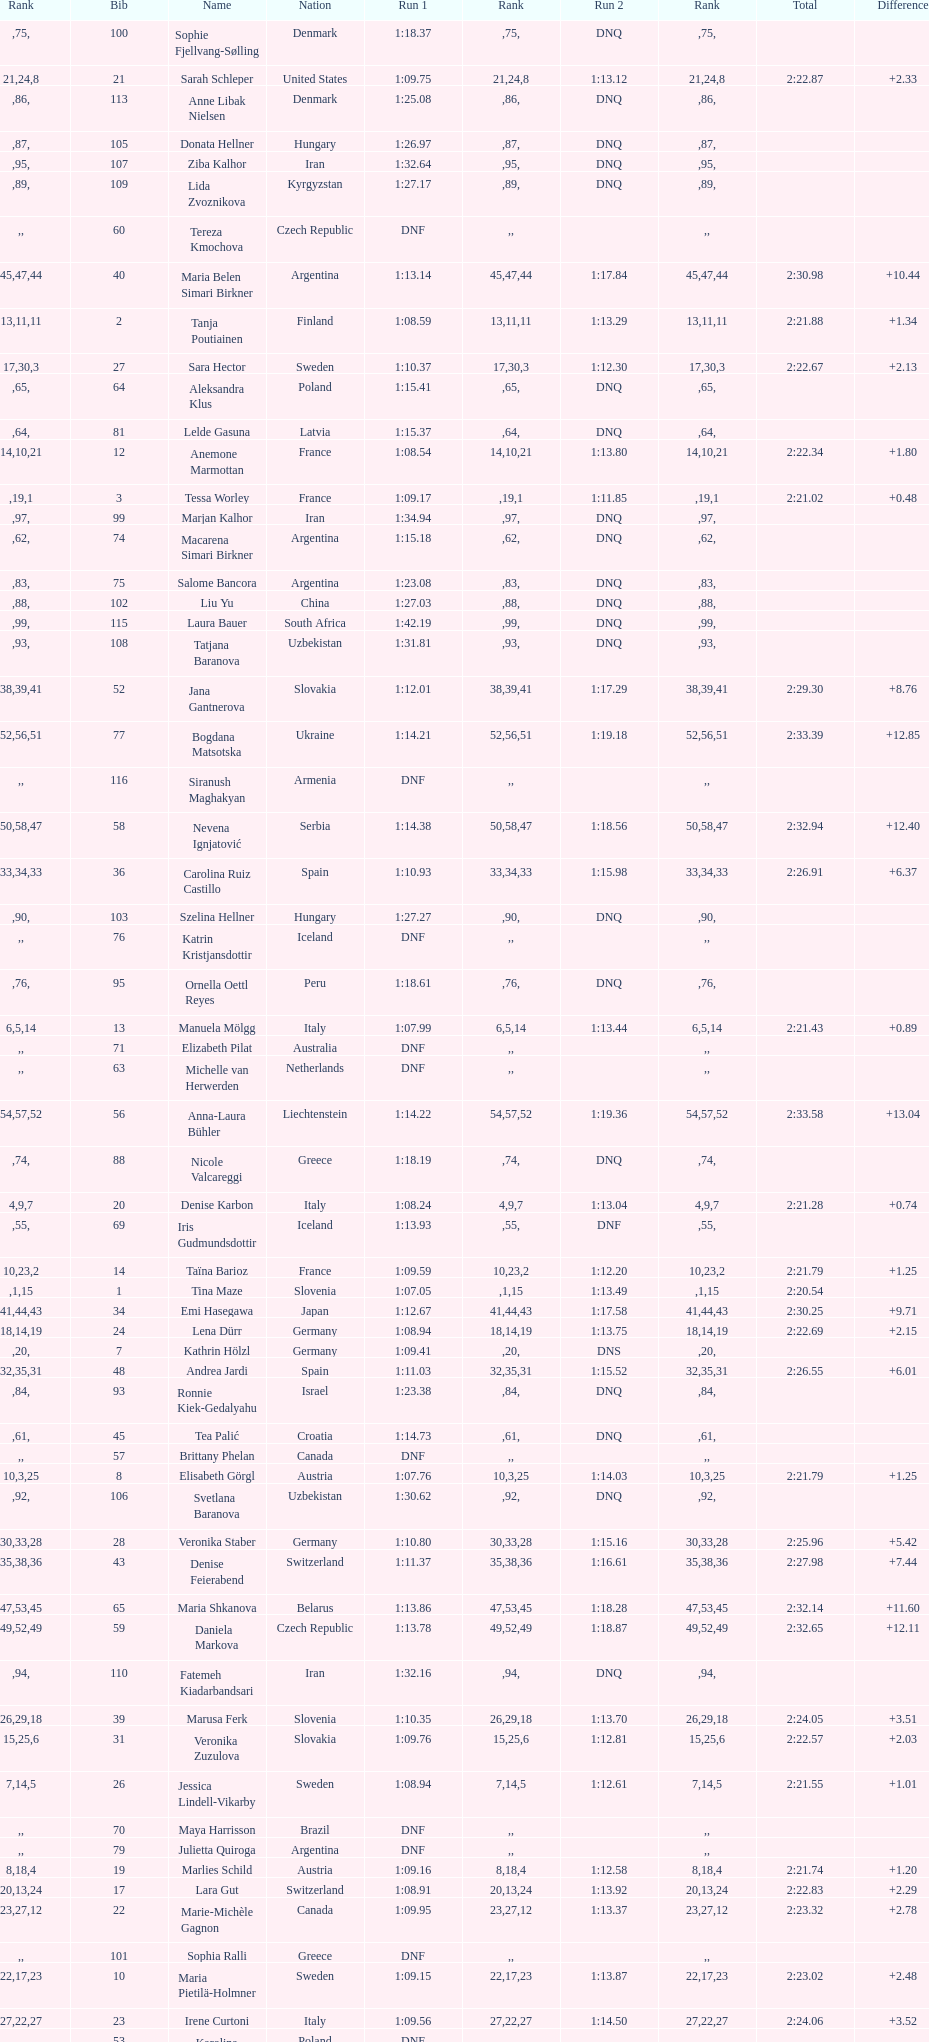How many total names are there? 116. 